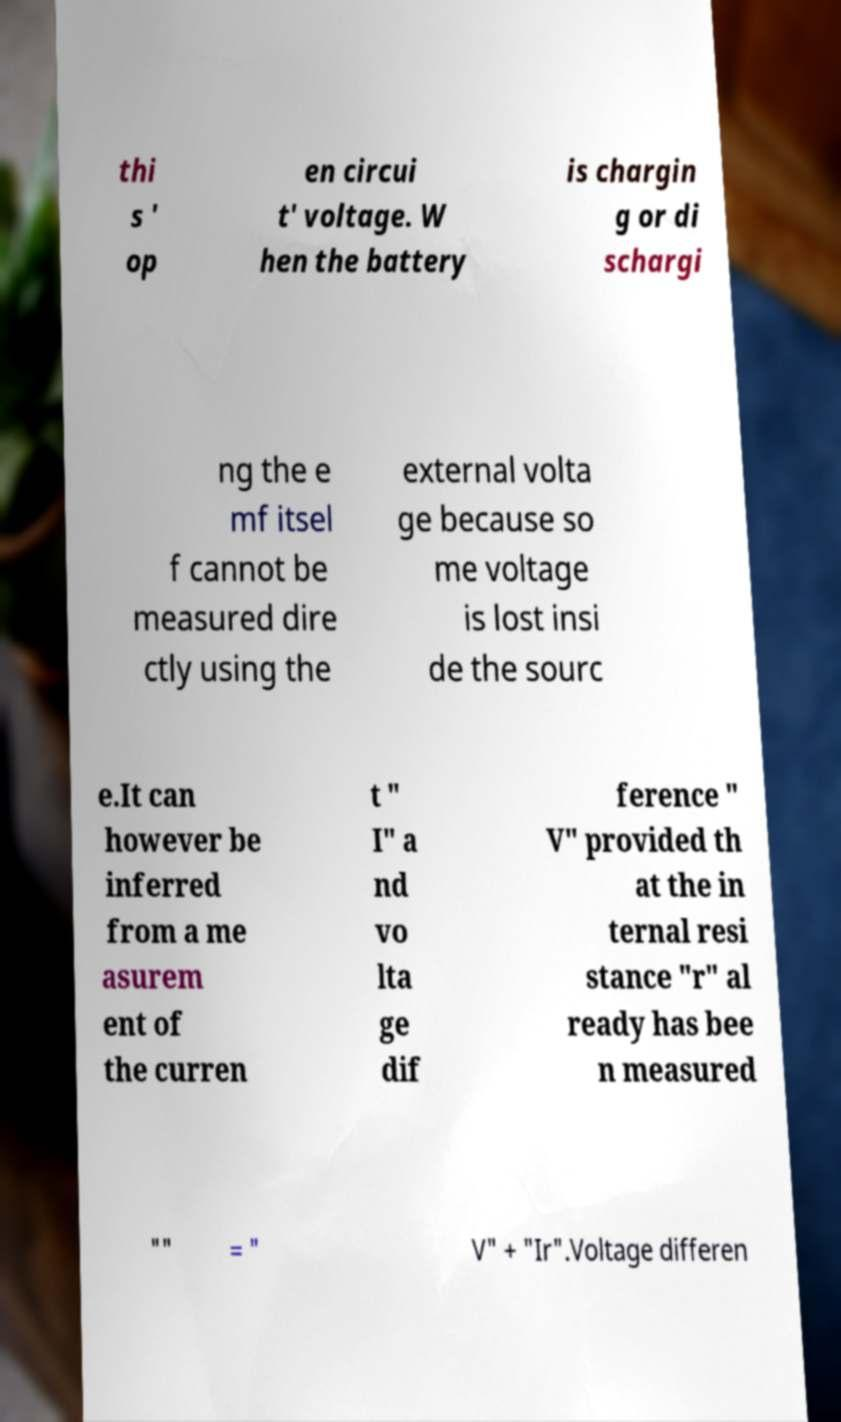Could you assist in decoding the text presented in this image and type it out clearly? thi s ' op en circui t' voltage. W hen the battery is chargin g or di schargi ng the e mf itsel f cannot be measured dire ctly using the external volta ge because so me voltage is lost insi de the sourc e.It can however be inferred from a me asurem ent of the curren t " I" a nd vo lta ge dif ference " V" provided th at the in ternal resi stance "r" al ready has bee n measured "" = " V" + "Ir".Voltage differen 